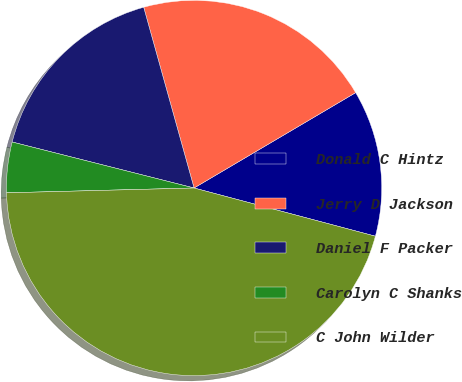Convert chart to OTSL. <chart><loc_0><loc_0><loc_500><loc_500><pie_chart><fcel>Donald C Hintz<fcel>Jerry D Jackson<fcel>Daniel F Packer<fcel>Carolyn C Shanks<fcel>C John Wilder<nl><fcel>12.62%<fcel>20.84%<fcel>16.73%<fcel>4.35%<fcel>45.45%<nl></chart> 